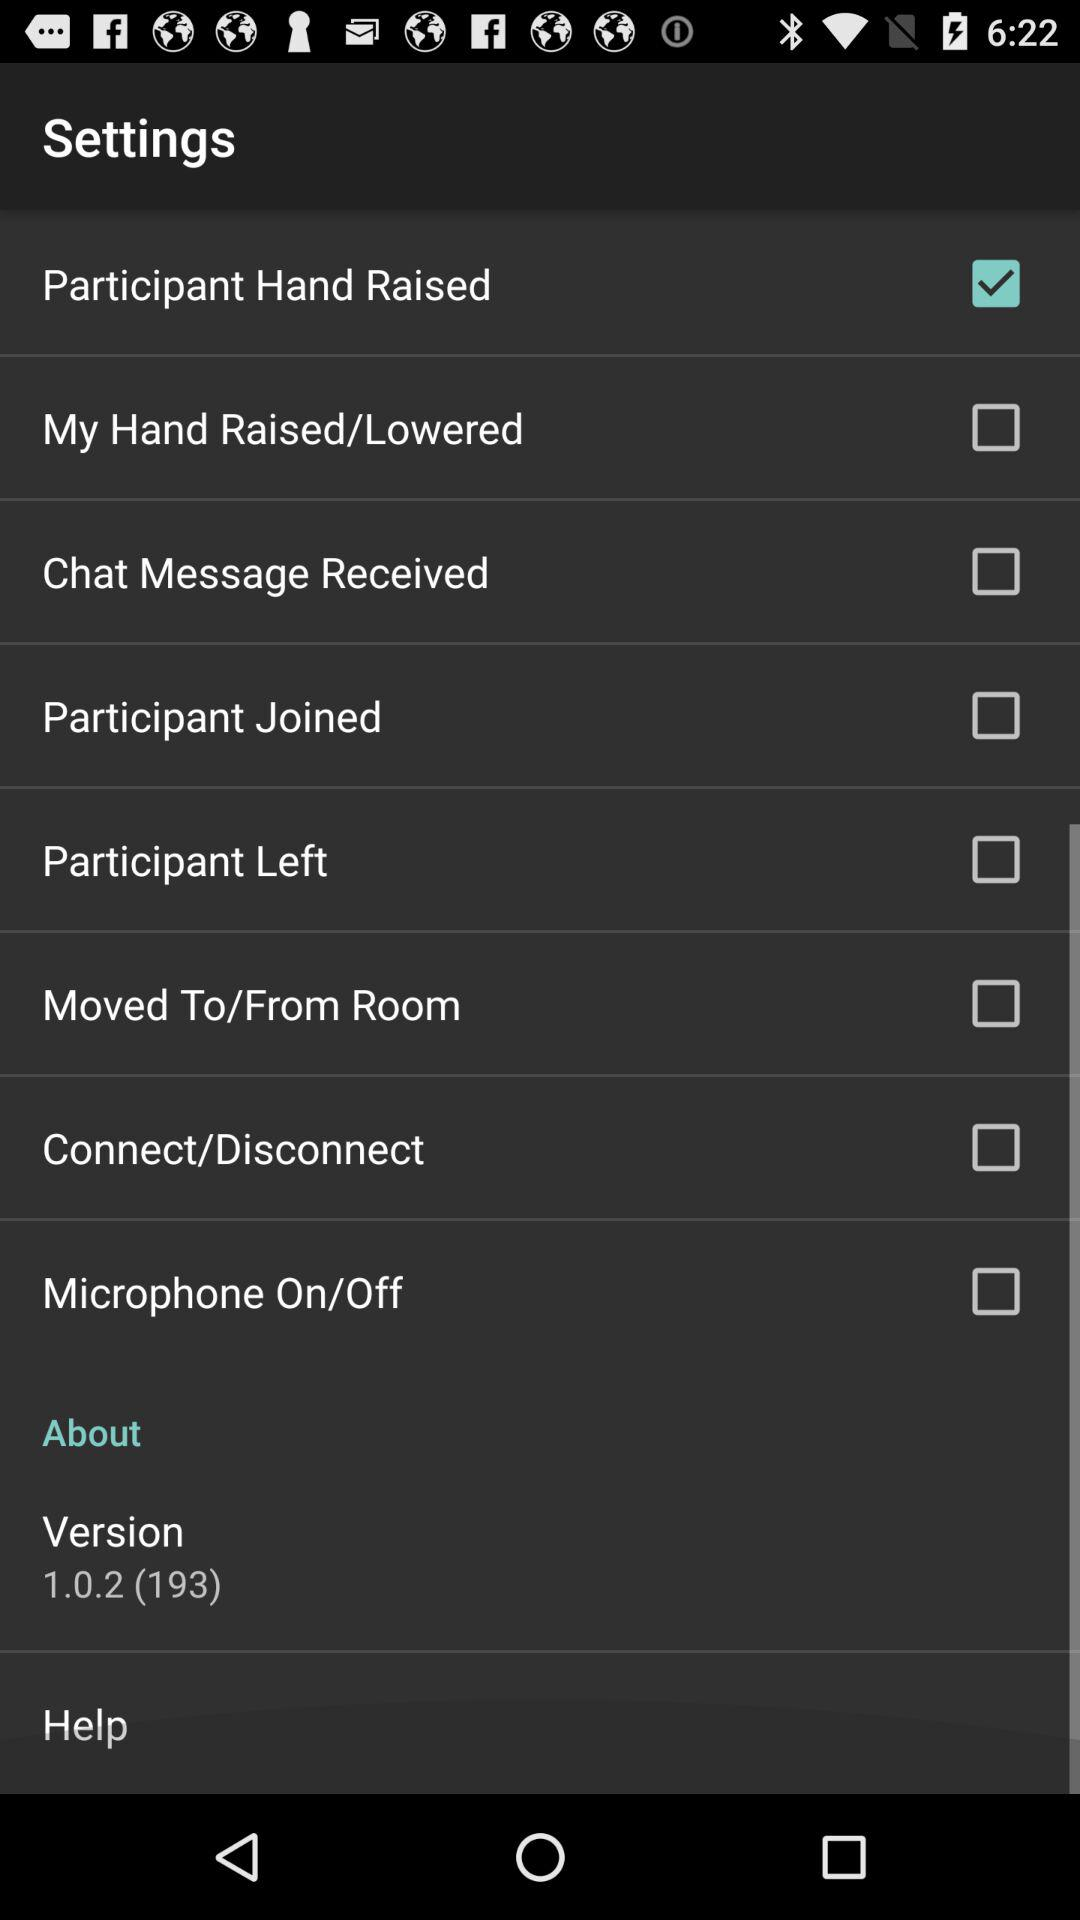What is the version? The version is 1.0.2 (193). 